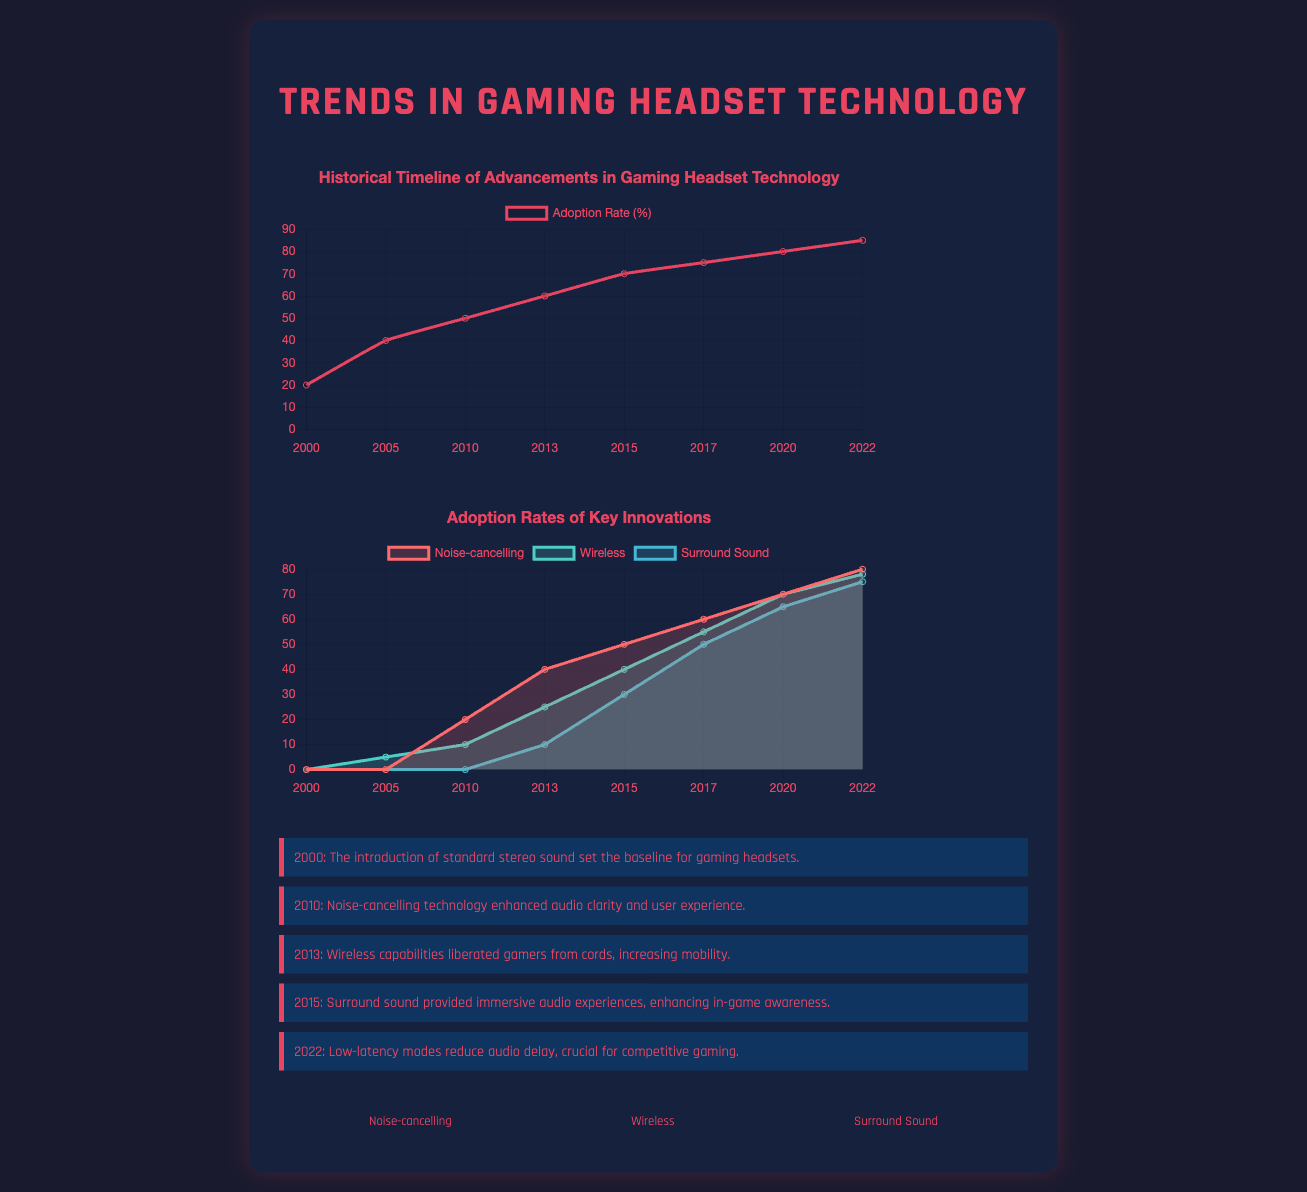What year introduced standard stereo sound? The document states that standard stereo sound was introduced in the year 2000.
Answer: 2000 What percentage of adoption was reached in 2015? According to the historical timeline chart, the adoption rate in 2015 was 70 percent.
Answer: 70 What key innovation was first mentioned in 2010? The document highlights noise-cancelling technology as a key innovation introduced in 2010.
Answer: Noise-cancelling What was the lowest adoption rate recorded for Wireless technology? The adoption rate for Wireless technology was lowest in the year 2005 at 5 percent.
Answer: 5 Which technology saw an adoption increase from 10% in 2013 to 75% in 2022? The surround sound technology increased from 10% in 2013 to 75% in 2022 according to the adoption rates chart.
Answer: Surround Sound What color represents Noise-cancelling in the adoption rates chart? The adoption rates chart shows that Noise-cancelling is represented by the color red.
Answer: Red In what year was low-latency mode mentioned? The infographic states that low-latency modes were highlighted in 2022.
Answer: 2022 What percentage of gamers adopted wireless capabilities by 2022? The document states that by 2022, the adoption rate for wireless capabilities reached 78 percent.
Answer: 78 What innovative technology is represented by the icon with a volume icon? The icon with a volume icon represents the Surround Sound technology.
Answer: Surround Sound 